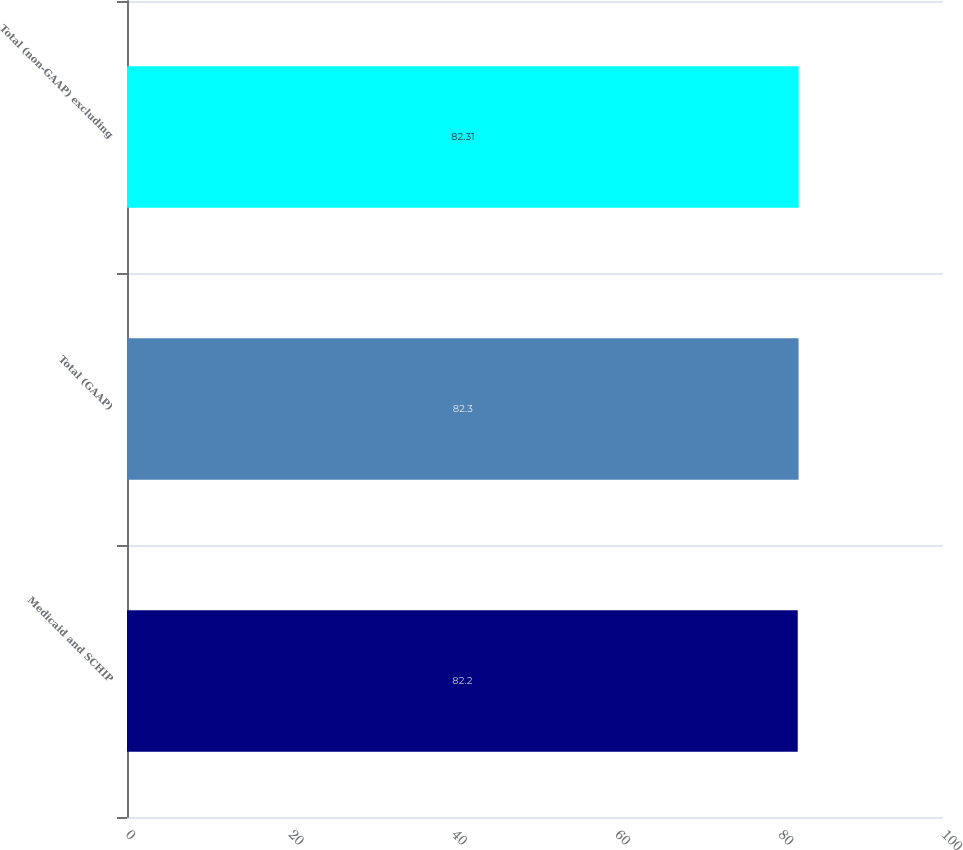<chart> <loc_0><loc_0><loc_500><loc_500><bar_chart><fcel>Medicaid and SCHIP<fcel>Total (GAAP)<fcel>Total (non-GAAP) excluding<nl><fcel>82.2<fcel>82.3<fcel>82.31<nl></chart> 